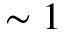<formula> <loc_0><loc_0><loc_500><loc_500>\sim 1</formula> 